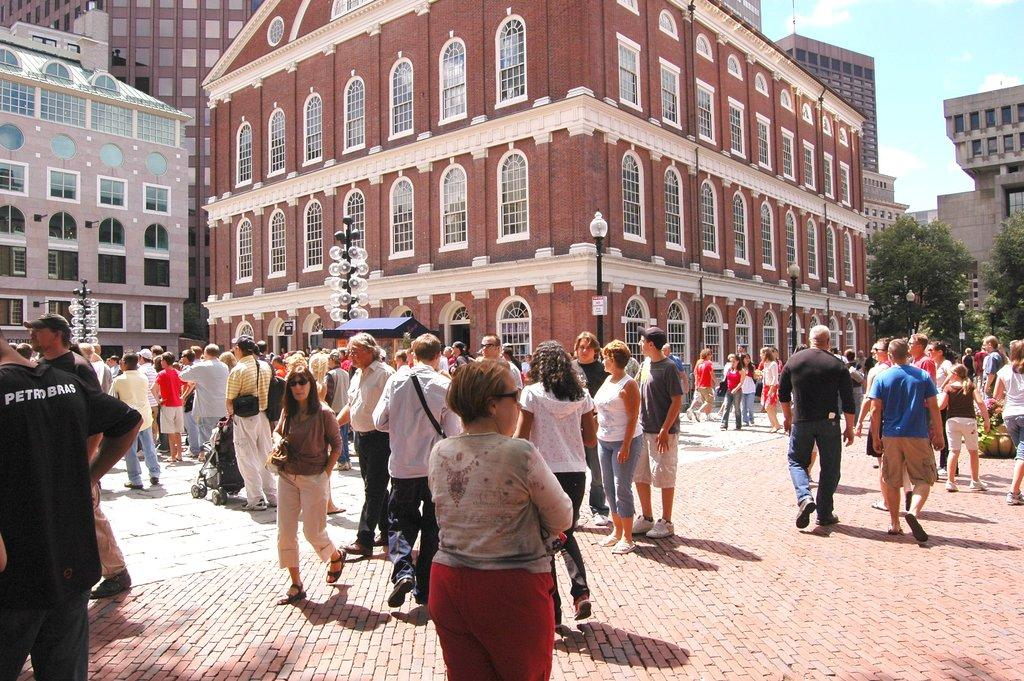<image>
Share a concise interpretation of the image provided. Crowd of people with a man to the left with PetraBras in white lettering on his shirt. 